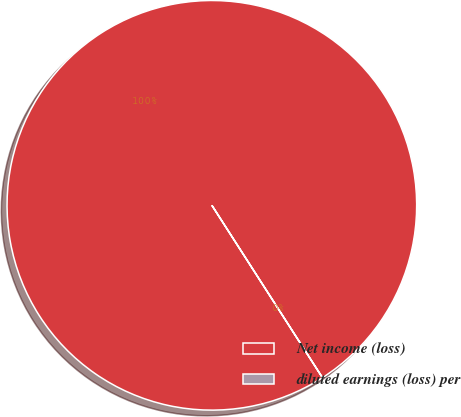<chart> <loc_0><loc_0><loc_500><loc_500><pie_chart><fcel>Net income (loss)<fcel>diluted earnings (loss) per<nl><fcel>100.0%<fcel>0.0%<nl></chart> 